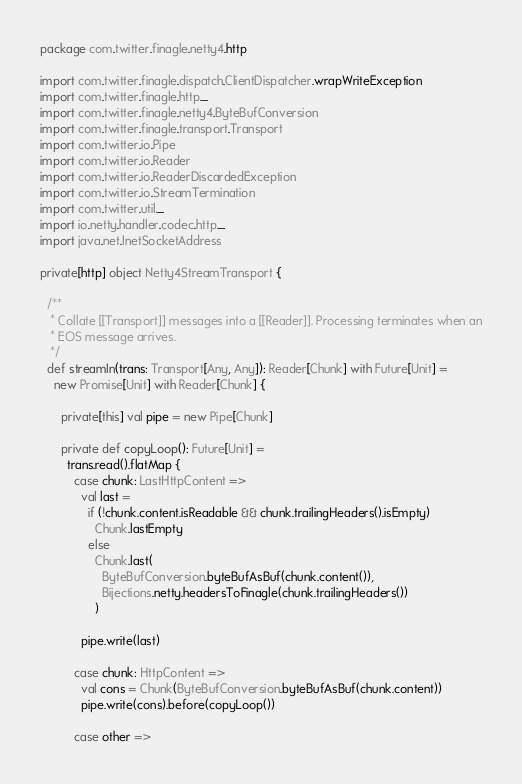Convert code to text. <code><loc_0><loc_0><loc_500><loc_500><_Scala_>package com.twitter.finagle.netty4.http

import com.twitter.finagle.dispatch.ClientDispatcher.wrapWriteException
import com.twitter.finagle.http._
import com.twitter.finagle.netty4.ByteBufConversion
import com.twitter.finagle.transport.Transport
import com.twitter.io.Pipe
import com.twitter.io.Reader
import com.twitter.io.ReaderDiscardedException
import com.twitter.io.StreamTermination
import com.twitter.util._
import io.netty.handler.codec.http._
import java.net.InetSocketAddress

private[http] object Netty4StreamTransport {

  /**
   * Collate [[Transport]] messages into a [[Reader]]. Processing terminates when an
   * EOS message arrives.
   */
  def streamIn(trans: Transport[Any, Any]): Reader[Chunk] with Future[Unit] =
    new Promise[Unit] with Reader[Chunk] {

      private[this] val pipe = new Pipe[Chunk]

      private def copyLoop(): Future[Unit] =
        trans.read().flatMap {
          case chunk: LastHttpContent =>
            val last =
              if (!chunk.content.isReadable && chunk.trailingHeaders().isEmpty)
                Chunk.lastEmpty
              else
                Chunk.last(
                  ByteBufConversion.byteBufAsBuf(chunk.content()),
                  Bijections.netty.headersToFinagle(chunk.trailingHeaders())
                )

            pipe.write(last)

          case chunk: HttpContent =>
            val cons = Chunk(ByteBufConversion.byteBufAsBuf(chunk.content))
            pipe.write(cons).before(copyLoop())

          case other =></code> 